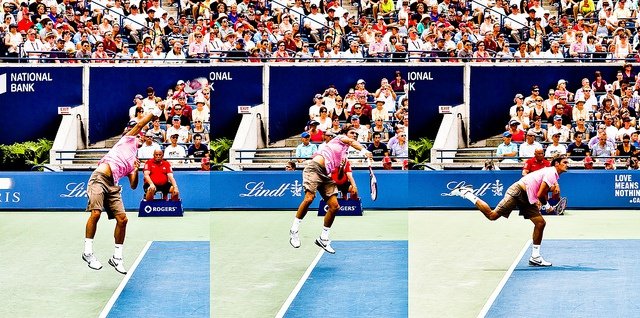Describe the objects in this image and their specific colors. I can see people in lightpink, white, black, and navy tones, people in salmon, white, black, maroon, and lightpink tones, people in salmon, white, black, maroon, and brown tones, people in salmon, white, black, maroon, and lightpink tones, and people in salmon, red, black, and maroon tones in this image. 